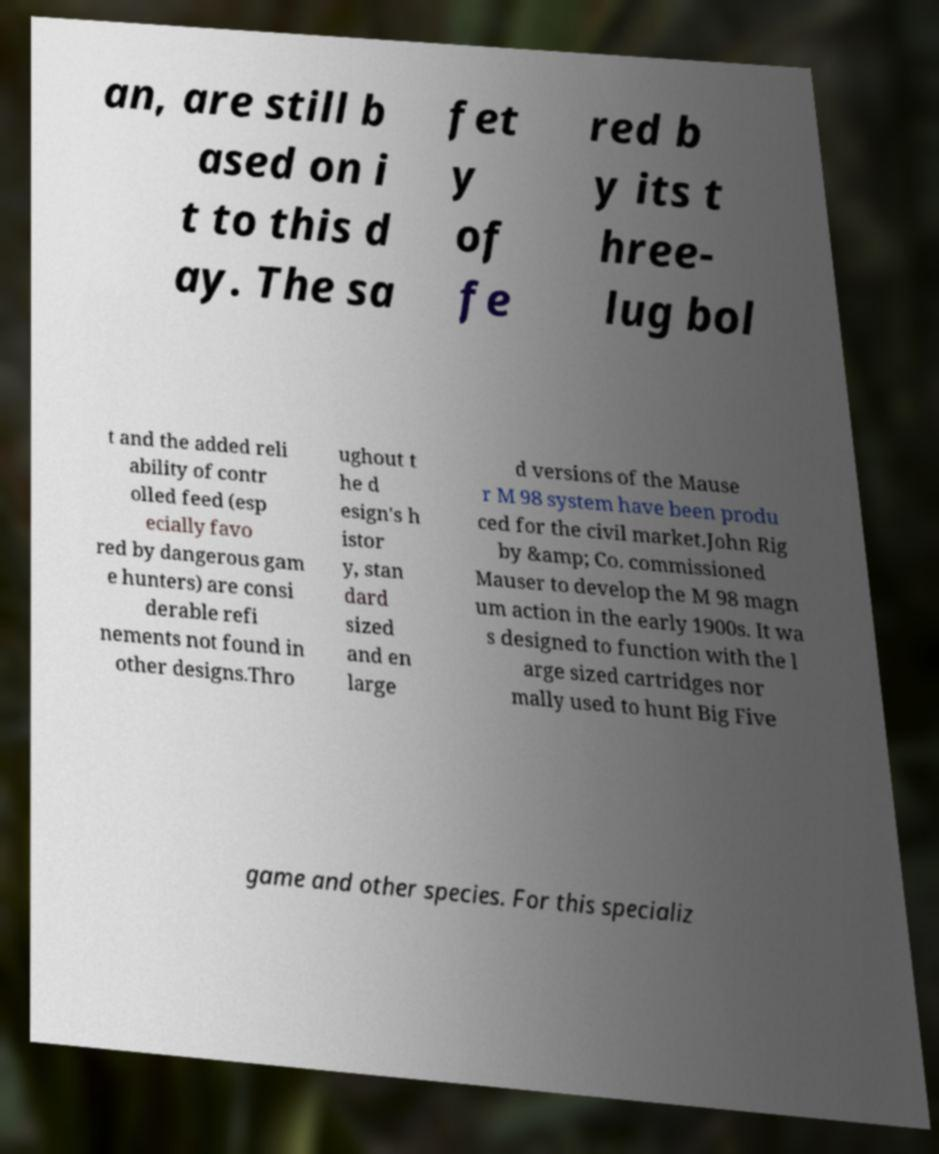Could you assist in decoding the text presented in this image and type it out clearly? an, are still b ased on i t to this d ay. The sa fet y of fe red b y its t hree- lug bol t and the added reli ability of contr olled feed (esp ecially favo red by dangerous gam e hunters) are consi derable refi nements not found in other designs.Thro ughout t he d esign's h istor y, stan dard sized and en large d versions of the Mause r M 98 system have been produ ced for the civil market.John Rig by &amp; Co. commissioned Mauser to develop the M 98 magn um action in the early 1900s. It wa s designed to function with the l arge sized cartridges nor mally used to hunt Big Five game and other species. For this specializ 